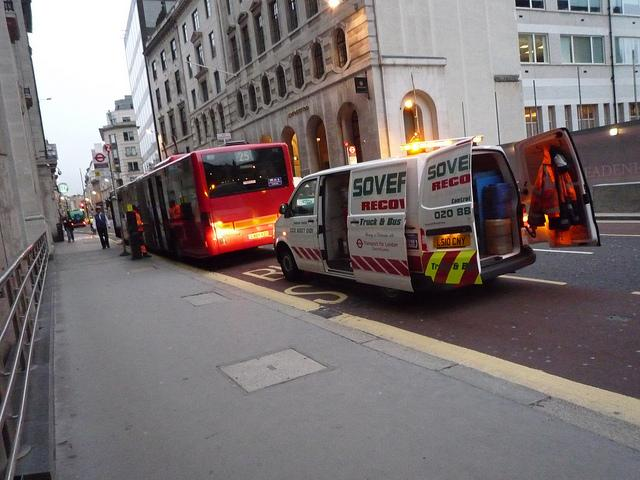Why is the red vehicle stopped here? Please explain your reasoning. boarding passengers. There is a sign on the side of the road and partial writing can be seen in the road lane stating that this is a bus stop. 